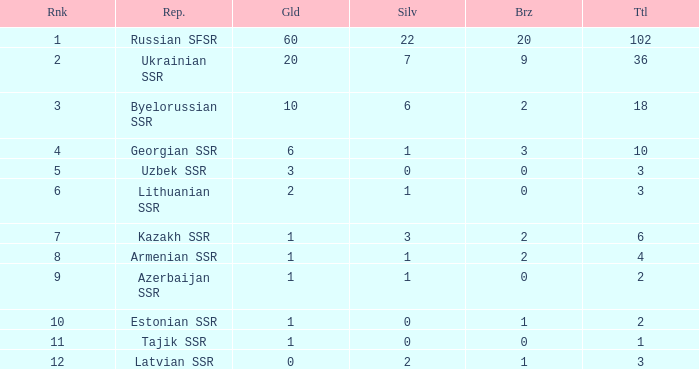What is the sum of silvers for teams with ranks over 3 and totals under 2? 0.0. 